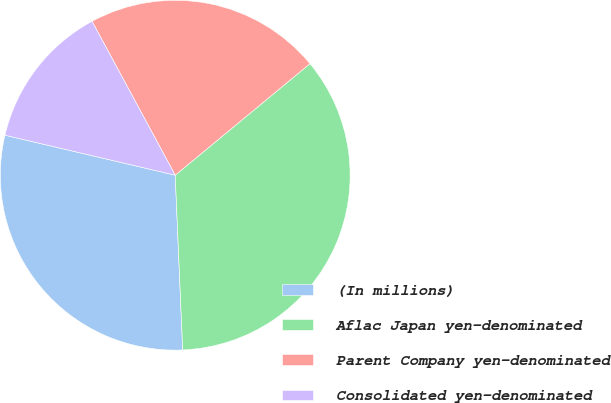Convert chart. <chart><loc_0><loc_0><loc_500><loc_500><pie_chart><fcel>(In millions)<fcel>Aflac Japan yen-denominated<fcel>Parent Company yen-denominated<fcel>Consolidated yen-denominated<nl><fcel>29.35%<fcel>35.32%<fcel>21.88%<fcel>13.44%<nl></chart> 